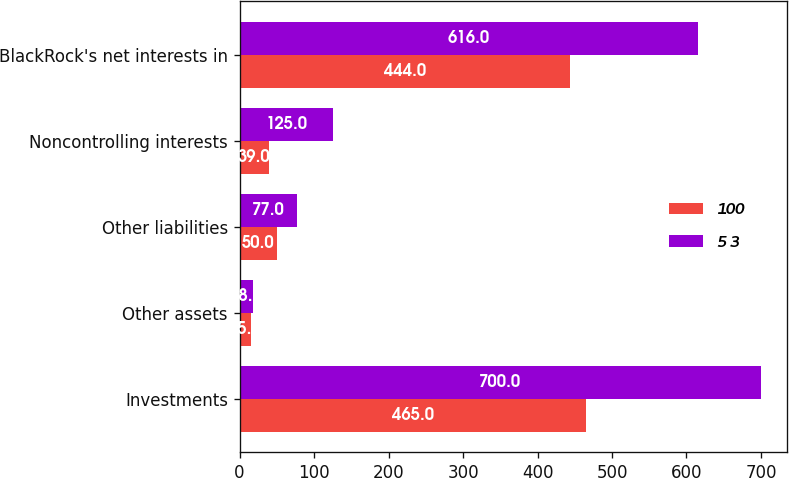Convert chart. <chart><loc_0><loc_0><loc_500><loc_500><stacked_bar_chart><ecel><fcel>Investments<fcel>Other assets<fcel>Other liabilities<fcel>Noncontrolling interests<fcel>BlackRock's net interests in<nl><fcel>100<fcel>465<fcel>15<fcel>50<fcel>39<fcel>444<nl><fcel>5 3<fcel>700<fcel>18<fcel>77<fcel>125<fcel>616<nl></chart> 